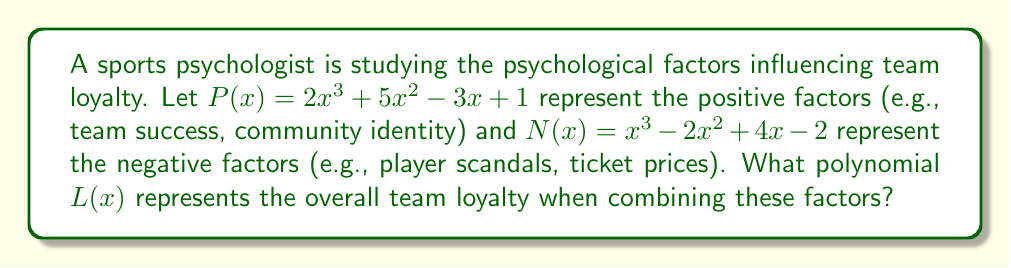Can you solve this math problem? To find the overall team loyalty polynomial $L(x)$, we need to add the positive factors $P(x)$ and subtract the negative factors $N(x)$. Let's approach this step-by-step:

1. Given:
   $P(x) = 2x^3 + 5x^2 - 3x + 1$
   $N(x) = x^3 - 2x^2 + 4x - 2$

2. We need to calculate $L(x) = P(x) - N(x)$

3. Subtract the polynomials term by term:
   $L(x) = (2x^3 + 5x^2 - 3x + 1) - (x^3 - 2x^2 + 4x - 2)$

4. Distribute the negative sign to the terms of $N(x)$:
   $L(x) = 2x^3 + 5x^2 - 3x + 1 - x^3 + 2x^2 - 4x + 2$

5. Combine like terms:
   - $x^3$ terms: $2x^3 - x^3 = x^3$
   - $x^2$ terms: $5x^2 + 2x^2 = 7x^2$
   - $x$ terms: $-3x - 4x = -7x$
   - Constants: $1 + 2 = 3$

6. Write the final polynomial:
   $L(x) = x^3 + 7x^2 - 7x + 3$

This polynomial $L(x)$ represents the overall team loyalty as a combination of positive and negative psychological factors.
Answer: $L(x) = x^3 + 7x^2 - 7x + 3$ 